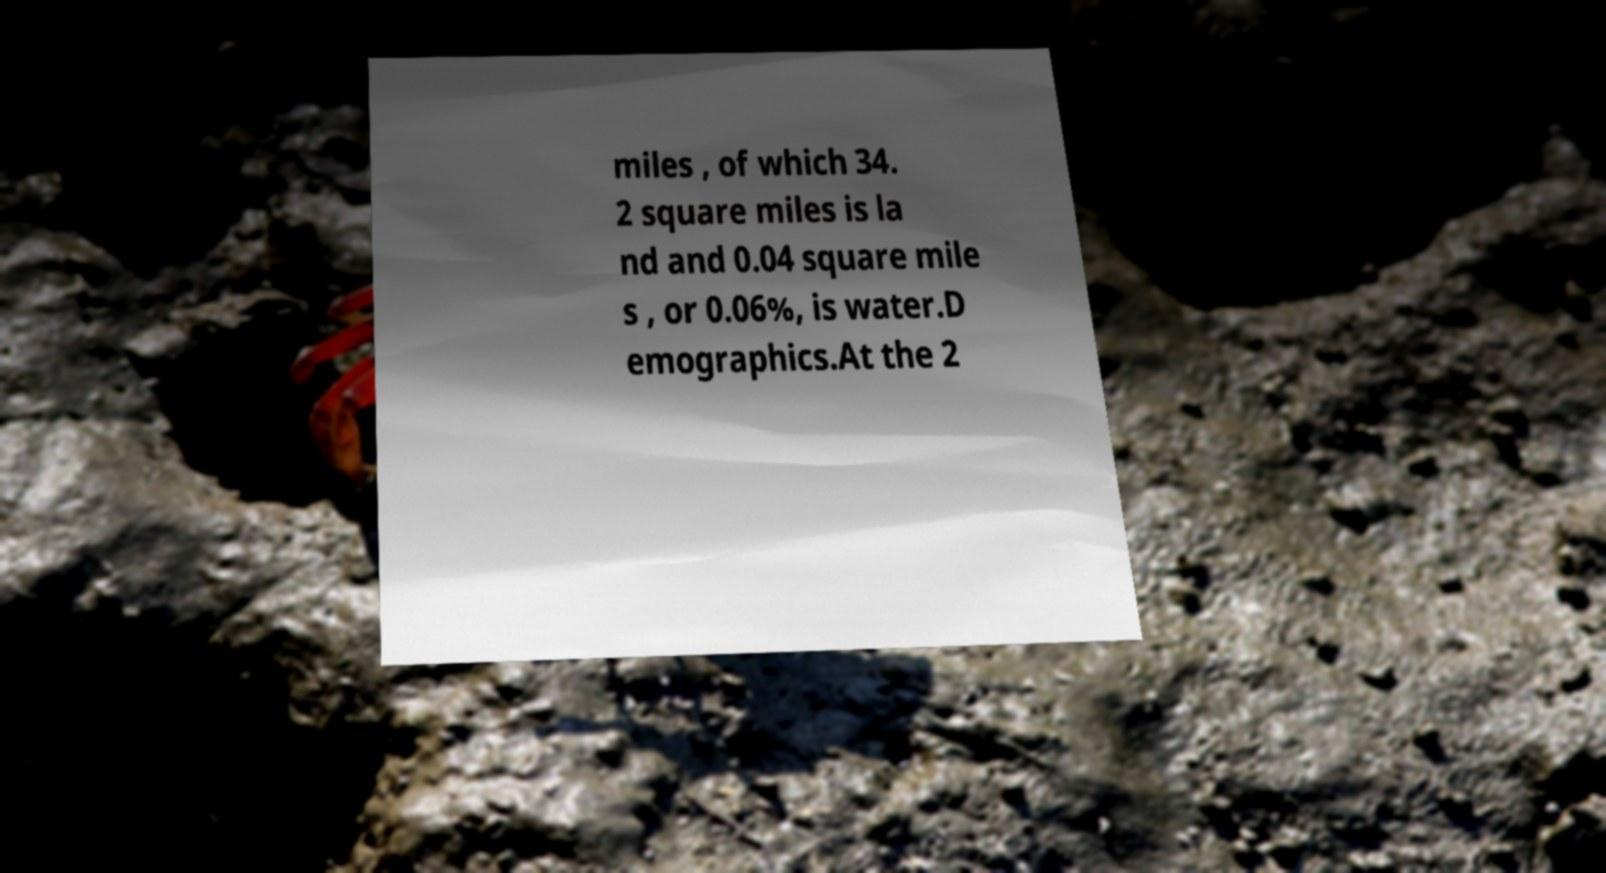Please read and relay the text visible in this image. What does it say? miles , of which 34. 2 square miles is la nd and 0.04 square mile s , or 0.06%, is water.D emographics.At the 2 